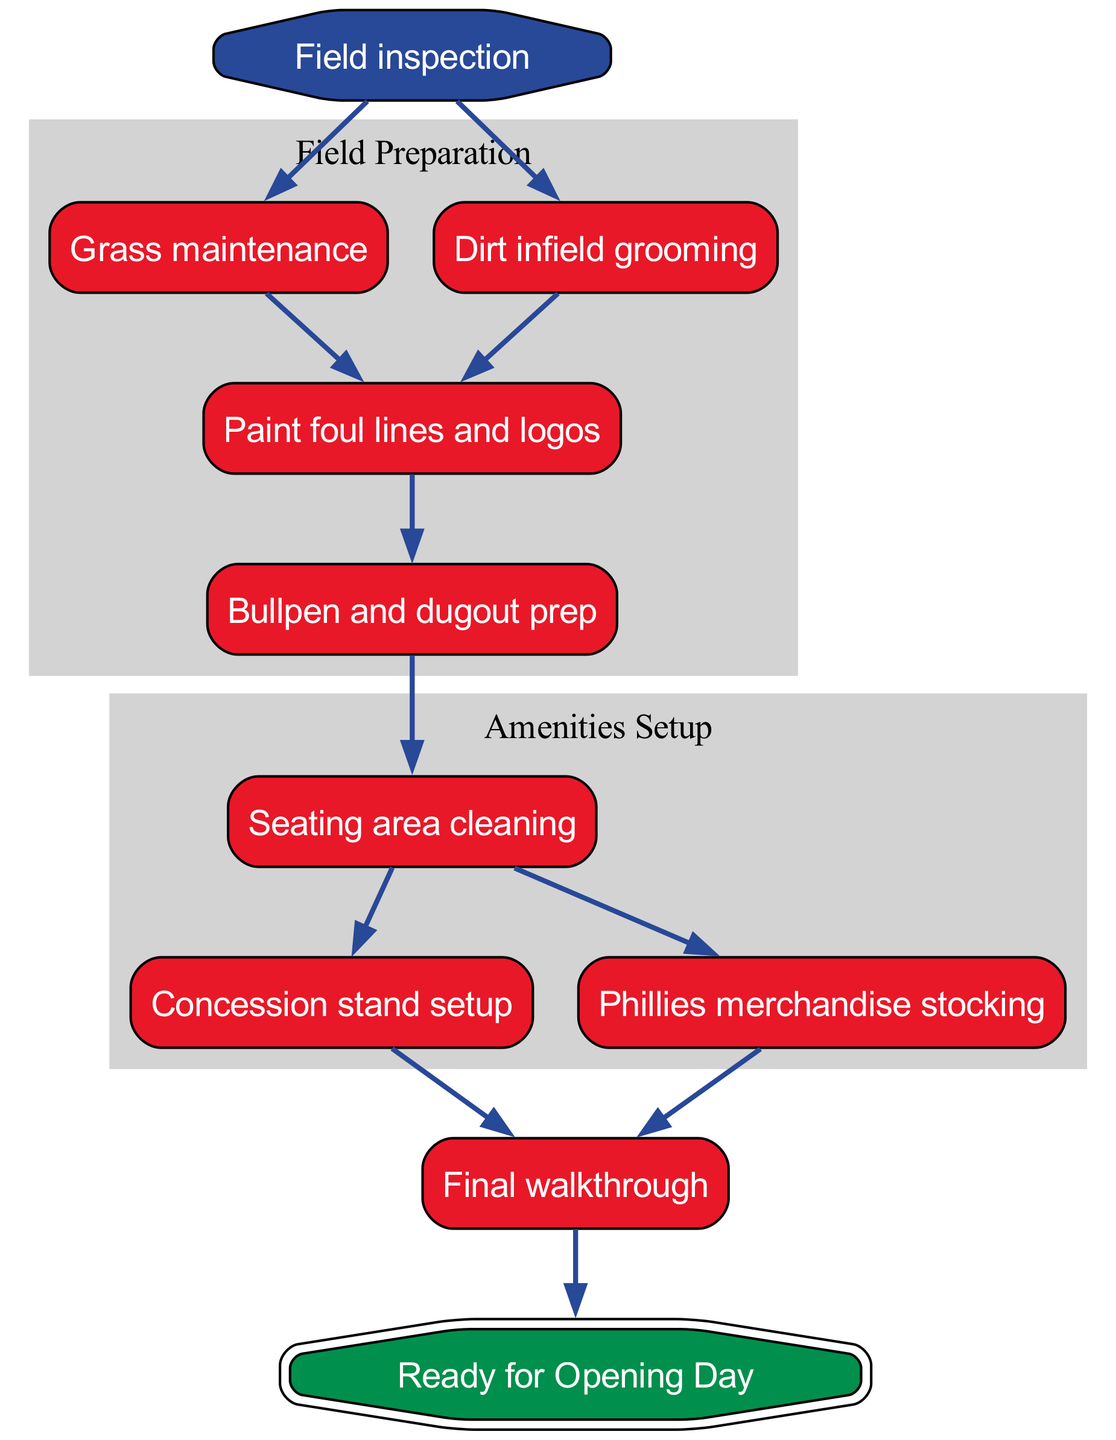What is the first step in preparing Citizens Bank Park for opening day? The diagram indicates that the first step in the process is "Field inspection." This is represented as the starting node and branches into two subsequent tasks.
Answer: Field inspection How many nodes are there in the diagram? By counting all the nodes depicted in the diagram, there are a total of ten distinct steps or tasks represented as nodes.
Answer: 10 Which two processes occur after the field inspection? From the "Field inspection" node, the two subsequent processes identified in the diagram are "Grass maintenance" and "Dirt infield grooming." Both lead to the next step in the process.
Answer: Grass maintenance, Dirt infield grooming What is the last step before the park is ready for opening day? The final step directly preceding "Ready for Opening Day," as shown in the diagram, is "Final walkthrough." This is essential to ensure everything is in order before the event.
Answer: Final walkthrough Which step involves cleaning the seating area? The diagram shows that "Seating area cleaning" is a specific task following the preparation of the field, indicated as happening after "Bullpen and dugout prep."
Answer: Seating area cleaning What are the two activities that follow cleaning the seating area? According to the flow of the diagram, after "Seating area cleaning," the next activities are "Concession stand setup" and "Phillies merchandise stocking." These are listed as tasks that occur simultaneously.
Answer: Concession stand setup, Phillies merchandise stocking How many tasks are in the Amenities Setup section of the diagram? The Amenities Setup section consists of three tasks, which are "Seating area cleaning," "Concession stand setup," and "Phillies merchandise stocking," all designed to prepare the park's amenities for guests.
Answer: 3 Which task comes after painting foul lines and logos? Following the task of "Paint foul lines and logos," the process moves to "Bullpen and dugout prep," indicating this step is essential in preparing the field for the game.
Answer: Bullpen and dugout prep 